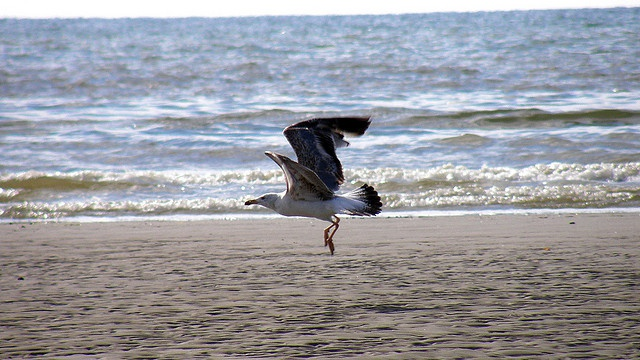Describe the objects in this image and their specific colors. I can see a bird in white, black, gray, and darkgray tones in this image. 